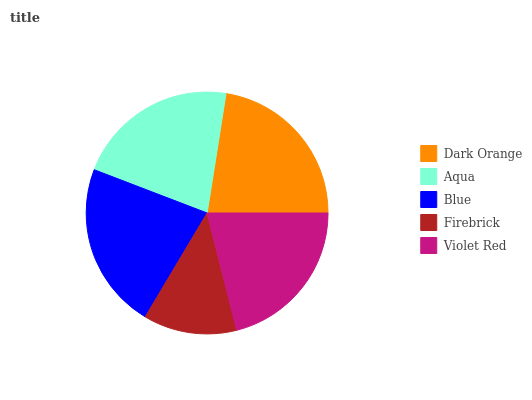Is Firebrick the minimum?
Answer yes or no. Yes. Is Dark Orange the maximum?
Answer yes or no. Yes. Is Aqua the minimum?
Answer yes or no. No. Is Aqua the maximum?
Answer yes or no. No. Is Dark Orange greater than Aqua?
Answer yes or no. Yes. Is Aqua less than Dark Orange?
Answer yes or no. Yes. Is Aqua greater than Dark Orange?
Answer yes or no. No. Is Dark Orange less than Aqua?
Answer yes or no. No. Is Aqua the high median?
Answer yes or no. Yes. Is Aqua the low median?
Answer yes or no. Yes. Is Blue the high median?
Answer yes or no. No. Is Dark Orange the low median?
Answer yes or no. No. 